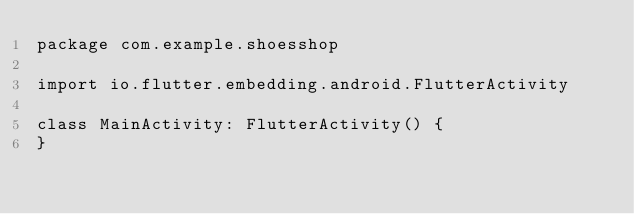Convert code to text. <code><loc_0><loc_0><loc_500><loc_500><_Kotlin_>package com.example.shoesshop

import io.flutter.embedding.android.FlutterActivity

class MainActivity: FlutterActivity() {
}
</code> 